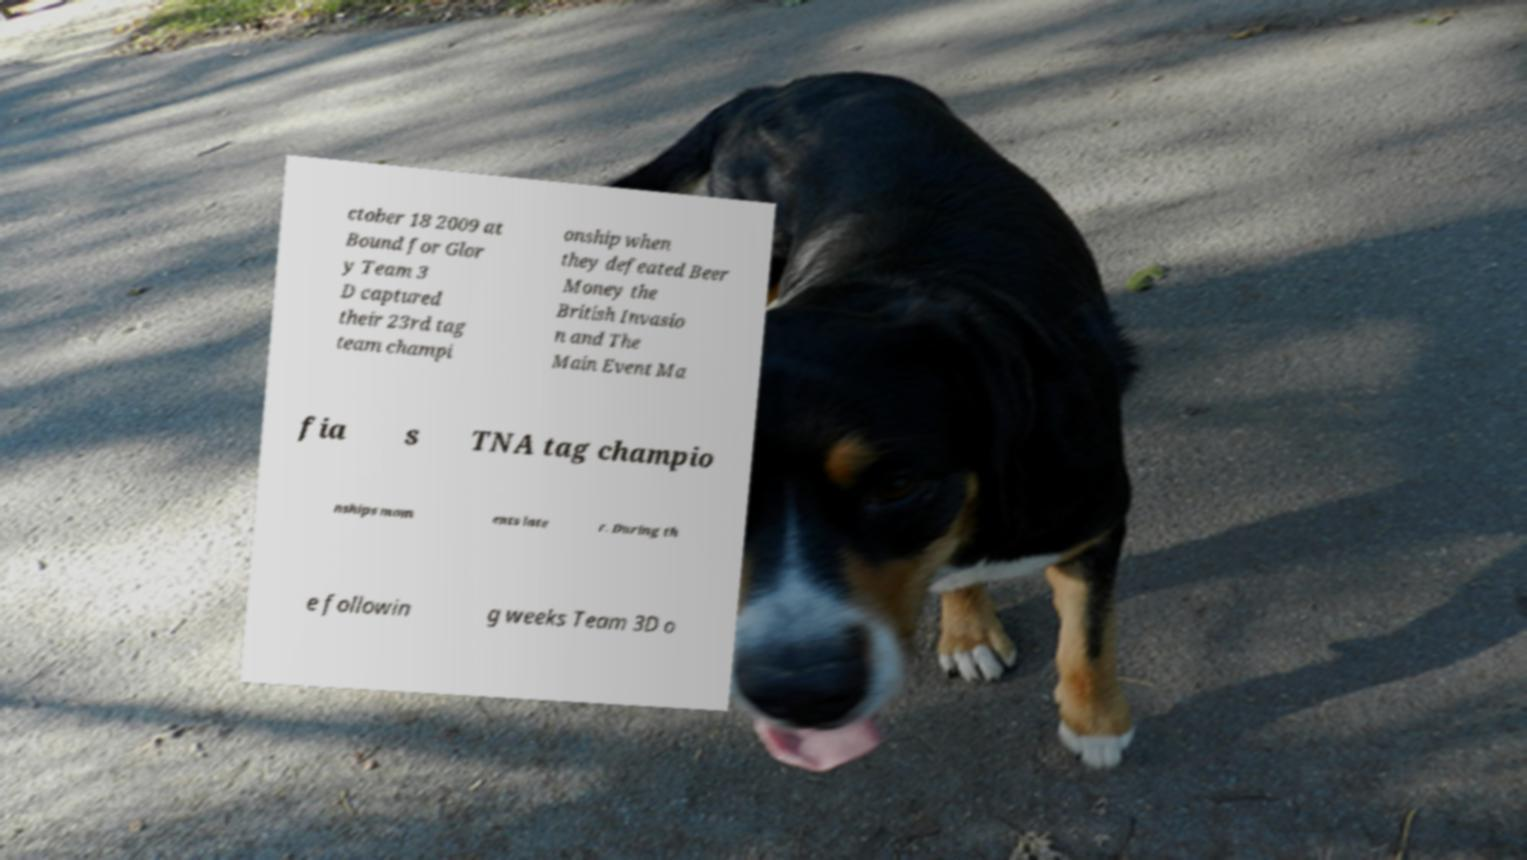What messages or text are displayed in this image? I need them in a readable, typed format. ctober 18 2009 at Bound for Glor y Team 3 D captured their 23rd tag team champi onship when they defeated Beer Money the British Invasio n and The Main Event Ma fia s TNA tag champio nships mom ents late r. During th e followin g weeks Team 3D o 